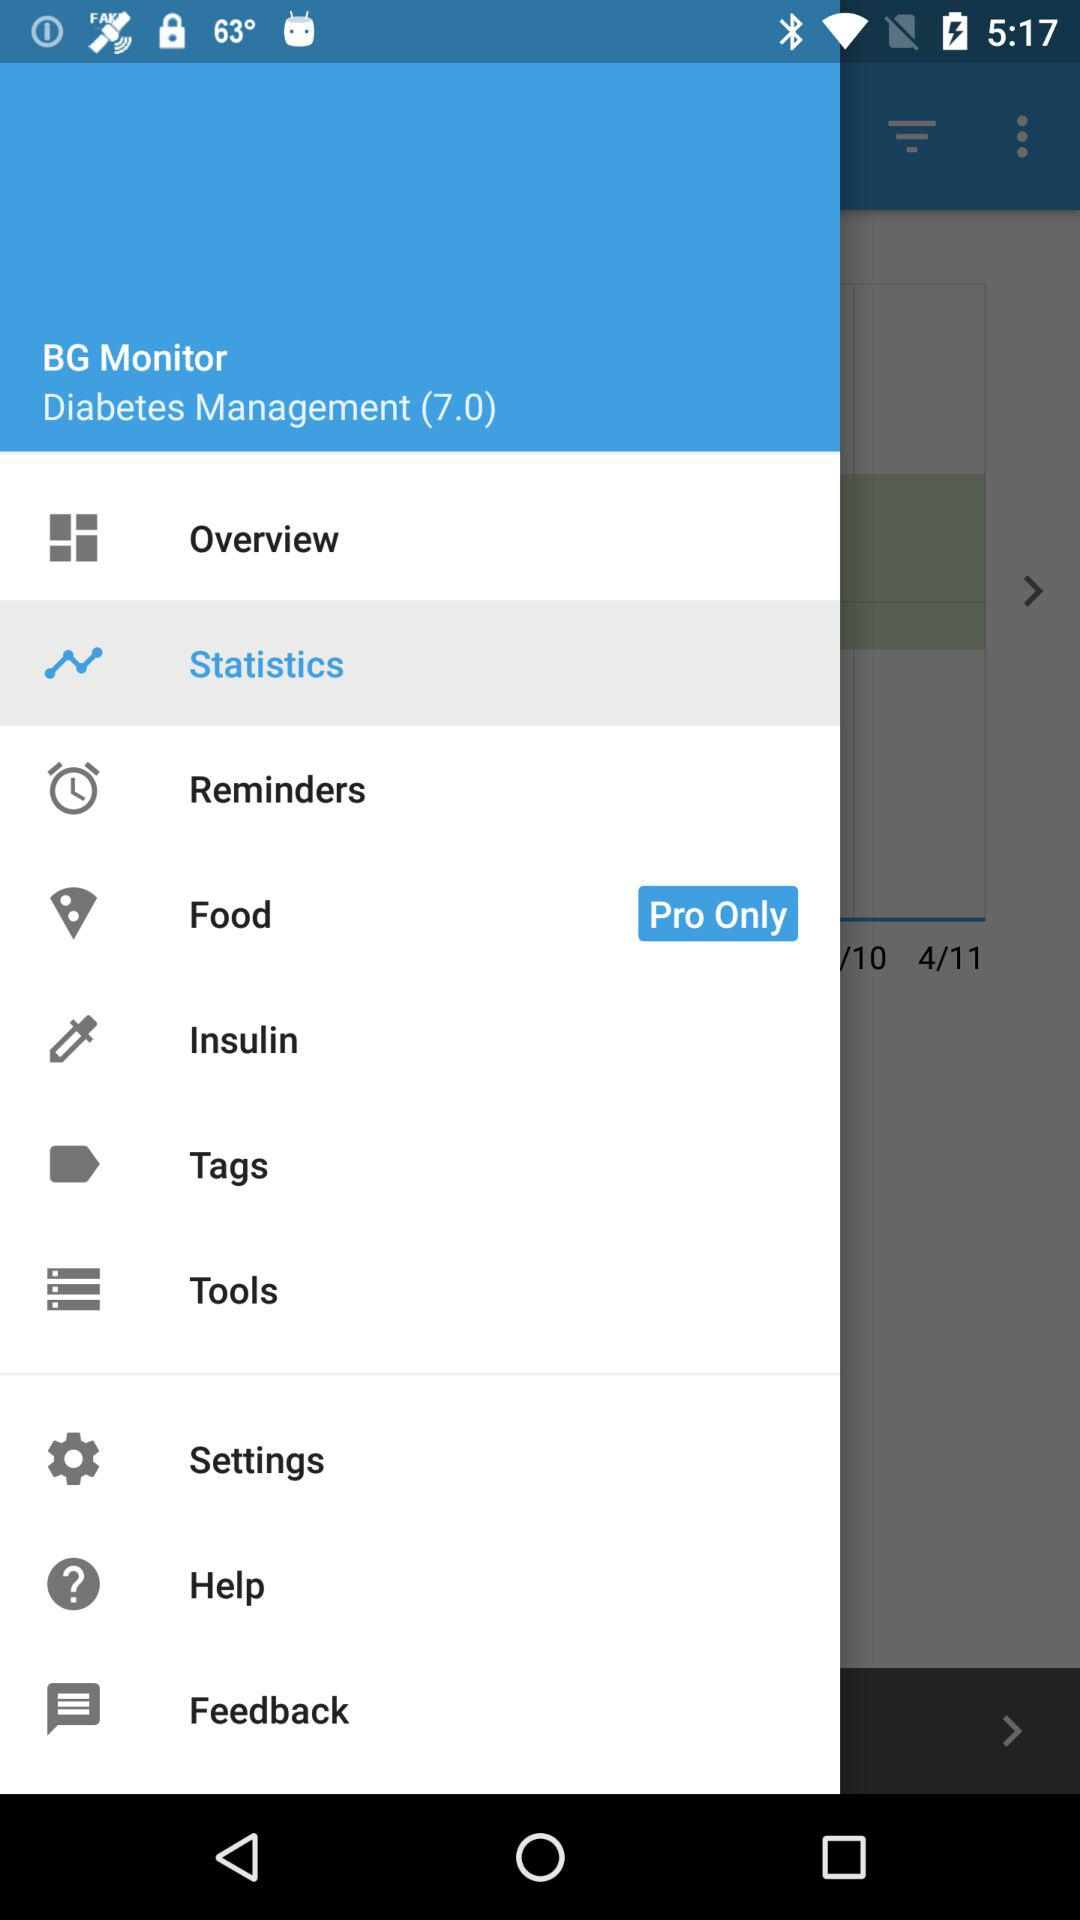Which item is available in the Pro Only version? The item that is available in the Pro Only version is "Food". 